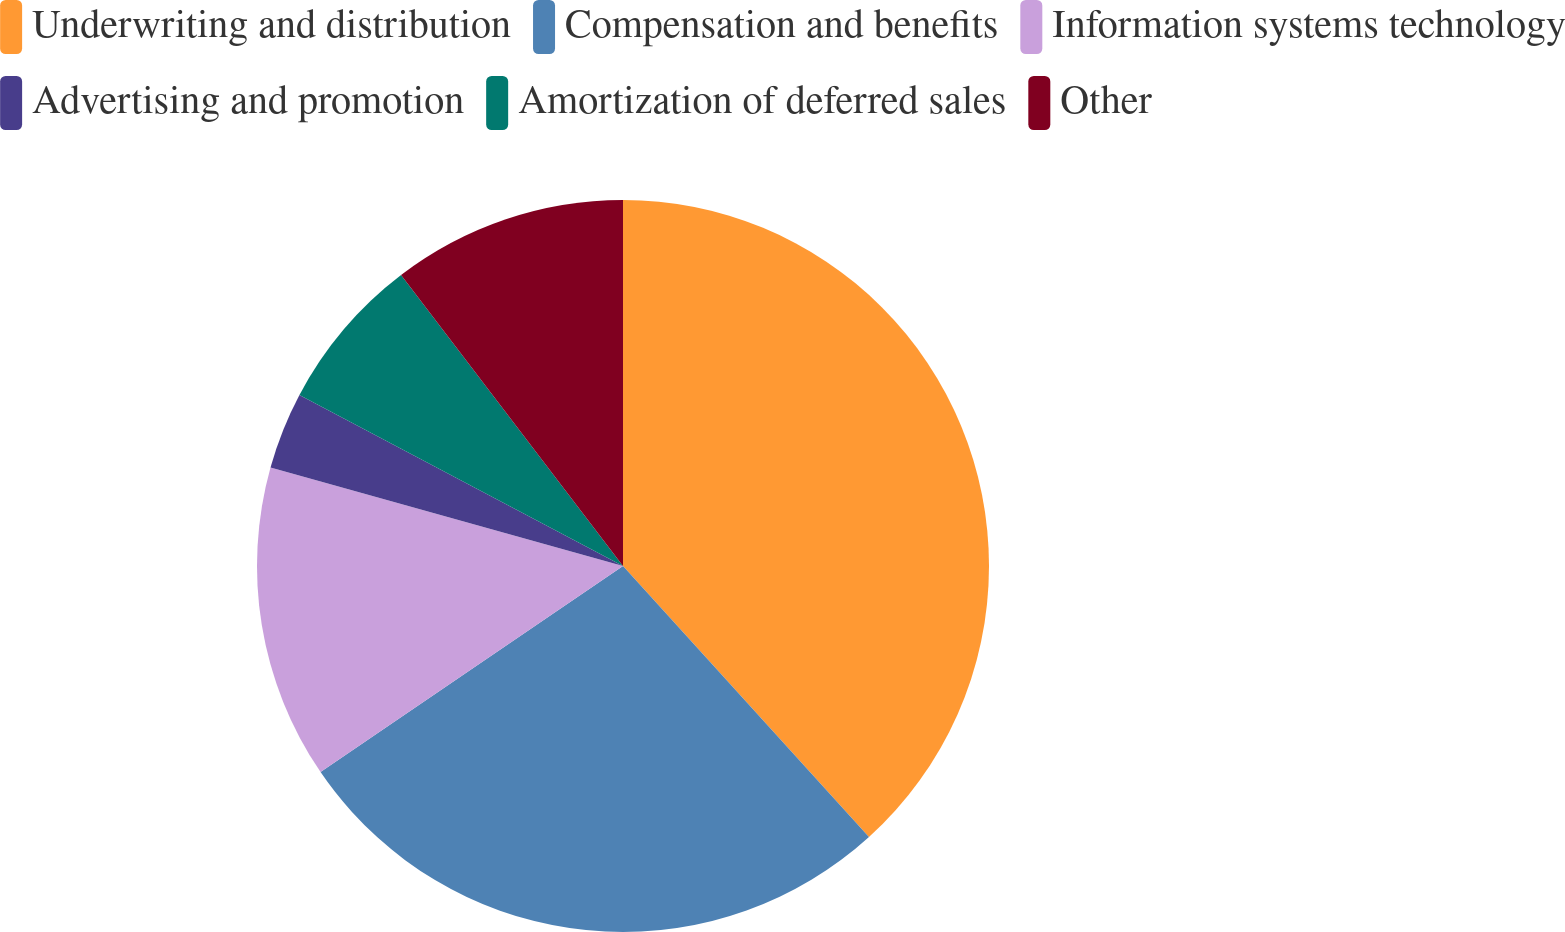Convert chart. <chart><loc_0><loc_0><loc_500><loc_500><pie_chart><fcel>Underwriting and distribution<fcel>Compensation and benefits<fcel>Information systems technology<fcel>Advertising and promotion<fcel>Amortization of deferred sales<fcel>Other<nl><fcel>38.27%<fcel>27.21%<fcel>13.86%<fcel>3.4%<fcel>6.89%<fcel>10.37%<nl></chart> 